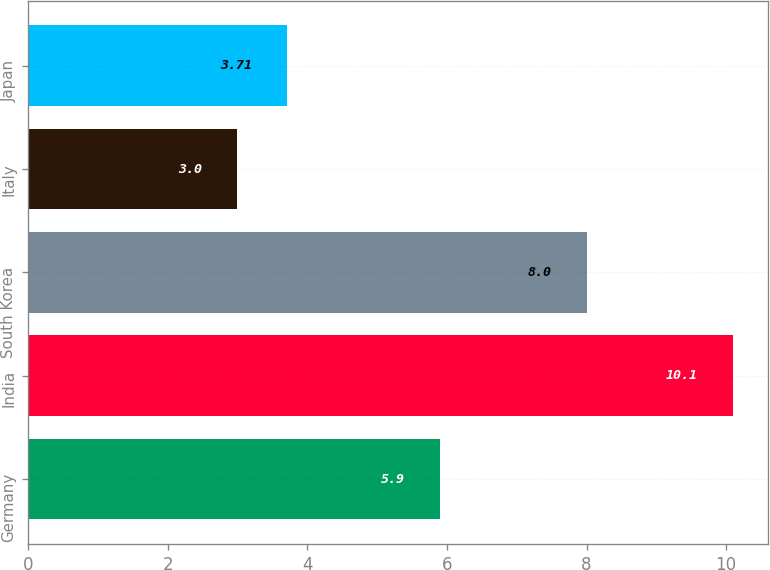Convert chart to OTSL. <chart><loc_0><loc_0><loc_500><loc_500><bar_chart><fcel>Germany<fcel>India<fcel>South Korea<fcel>Italy<fcel>Japan<nl><fcel>5.9<fcel>10.1<fcel>8<fcel>3<fcel>3.71<nl></chart> 